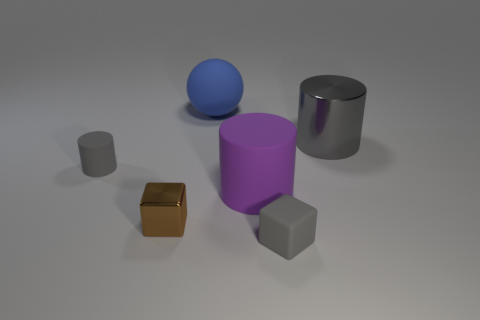There is a purple thing that is the same material as the big sphere; what shape is it?
Keep it short and to the point. Cylinder. There is a matte cylinder that is the same size as the gray metal cylinder; what is its color?
Offer a terse response. Purple. What color is the tiny thing that is both on the right side of the small gray rubber cylinder and to the left of the small gray rubber block?
Provide a succinct answer. Brown. The rubber object that is the same color as the tiny cylinder is what size?
Your response must be concise. Small. What is the shape of the metal object that is the same color as the tiny rubber block?
Provide a succinct answer. Cylinder. There is a cylinder that is in front of the gray thing that is left of the thing that is in front of the brown shiny object; how big is it?
Your response must be concise. Large. Are the big blue thing and the large thing that is in front of the metallic cylinder made of the same material?
Ensure brevity in your answer.  Yes. There is a cylinder that is right of the purple matte cylinder that is in front of the gray metal cylinder; are there any tiny cylinders in front of it?
Your answer should be compact. Yes. Does the gray metallic thing have the same shape as the small rubber object that is in front of the purple thing?
Your response must be concise. No. There is a rubber cylinder that is left of the large thing behind the metallic thing behind the tiny rubber cylinder; what color is it?
Offer a very short reply. Gray. 